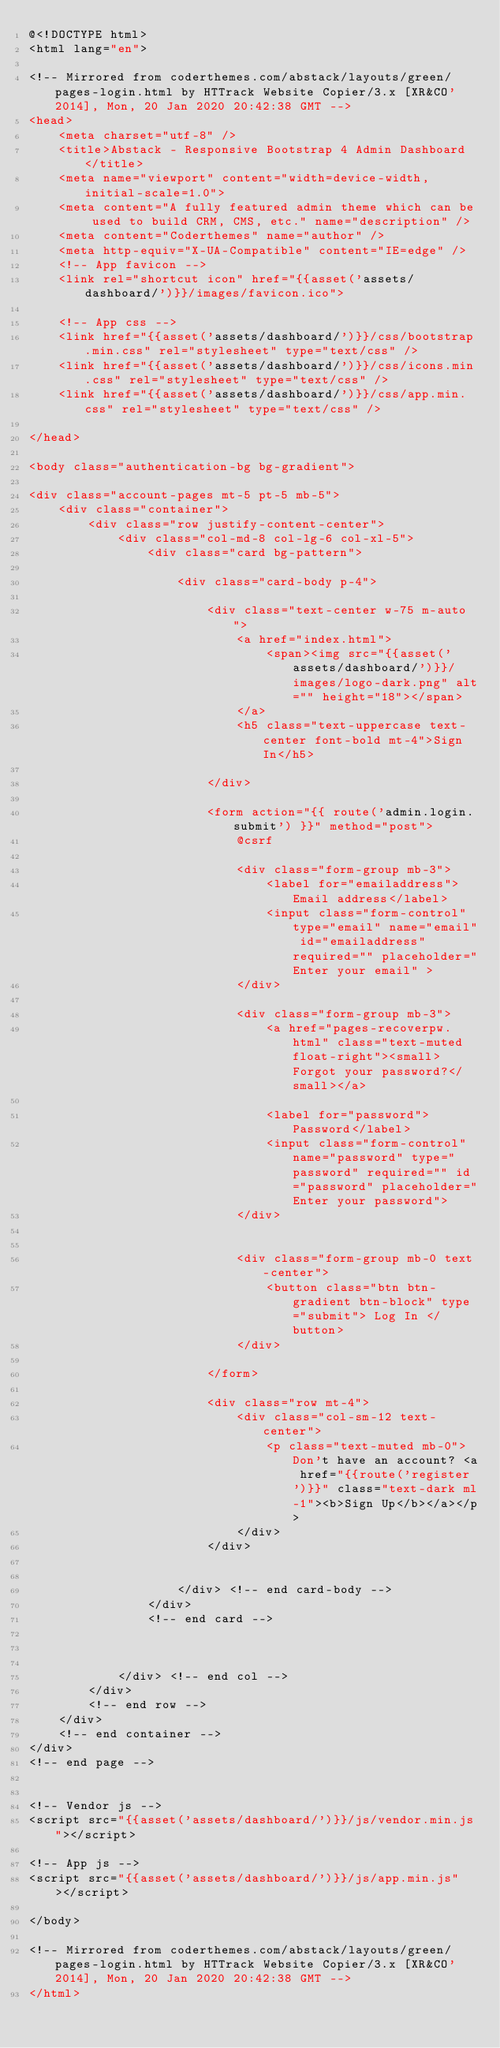Convert code to text. <code><loc_0><loc_0><loc_500><loc_500><_PHP_>@<!DOCTYPE html>
<html lang="en">

<!-- Mirrored from coderthemes.com/abstack/layouts/green/pages-login.html by HTTrack Website Copier/3.x [XR&CO'2014], Mon, 20 Jan 2020 20:42:38 GMT -->
<head>
    <meta charset="utf-8" />
    <title>Abstack - Responsive Bootstrap 4 Admin Dashboard</title>
    <meta name="viewport" content="width=device-width, initial-scale=1.0">
    <meta content="A fully featured admin theme which can be used to build CRM, CMS, etc." name="description" />
    <meta content="Coderthemes" name="author" />
    <meta http-equiv="X-UA-Compatible" content="IE=edge" />
    <!-- App favicon -->
    <link rel="shortcut icon" href="{{asset('assets/dashboard/')}}/images/favicon.ico">

    <!-- App css -->
    <link href="{{asset('assets/dashboard/')}}/css/bootstrap.min.css" rel="stylesheet" type="text/css" />
    <link href="{{asset('assets/dashboard/')}}/css/icons.min.css" rel="stylesheet" type="text/css" />
    <link href="{{asset('assets/dashboard/')}}/css/app.min.css" rel="stylesheet" type="text/css" />

</head>

<body class="authentication-bg bg-gradient">

<div class="account-pages mt-5 pt-5 mb-5">
    <div class="container">
        <div class="row justify-content-center">
            <div class="col-md-8 col-lg-6 col-xl-5">
                <div class="card bg-pattern">

                    <div class="card-body p-4">

                        <div class="text-center w-75 m-auto">
                            <a href="index.html">
                                <span><img src="{{asset('assets/dashboard/')}}/images/logo-dark.png" alt="" height="18"></span>
                            </a>
                            <h5 class="text-uppercase text-center font-bold mt-4">Sign In</h5>

                        </div>

                        <form action="{{ route('admin.login.submit') }}" method="post">
                            @csrf

                            <div class="form-group mb-3">
                                <label for="emailaddress">Email address</label>
                                <input class="form-control" type="email" name="email" id="emailaddress" required="" placeholder="Enter your email" >
                            </div>

                            <div class="form-group mb-3">
                                <a href="pages-recoverpw.html" class="text-muted float-right"><small>Forgot your password?</small></a>

                                <label for="password">Password</label>
                                <input class="form-control" name="password" type="password" required="" id="password" placeholder="Enter your password">
                            </div>


                            <div class="form-group mb-0 text-center">
                                <button class="btn btn-gradient btn-block" type="submit"> Log In </button>
                            </div>

                        </form>

                        <div class="row mt-4">
                            <div class="col-sm-12 text-center">
                                <p class="text-muted mb-0">Don't have an account? <a href="{{route('register')}}" class="text-dark ml-1"><b>Sign Up</b></a></p>
                            </div>
                        </div>


                    </div> <!-- end card-body -->
                </div>
                <!-- end card -->



            </div> <!-- end col -->
        </div>
        <!-- end row -->
    </div>
    <!-- end container -->
</div>
<!-- end page -->


<!-- Vendor js -->
<script src="{{asset('assets/dashboard/')}}/js/vendor.min.js"></script>

<!-- App js -->
<script src="{{asset('assets/dashboard/')}}/js/app.min.js"></script>

</body>

<!-- Mirrored from coderthemes.com/abstack/layouts/green/pages-login.html by HTTrack Website Copier/3.x [XR&CO'2014], Mon, 20 Jan 2020 20:42:38 GMT -->
</html>


</code> 